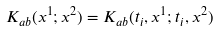Convert formula to latex. <formula><loc_0><loc_0><loc_500><loc_500>K _ { a b } ( x ^ { 1 } ; x ^ { 2 } ) = K _ { a b } ( t _ { i } , { x } ^ { 1 } ; t _ { i } , { x } ^ { 2 } )</formula> 